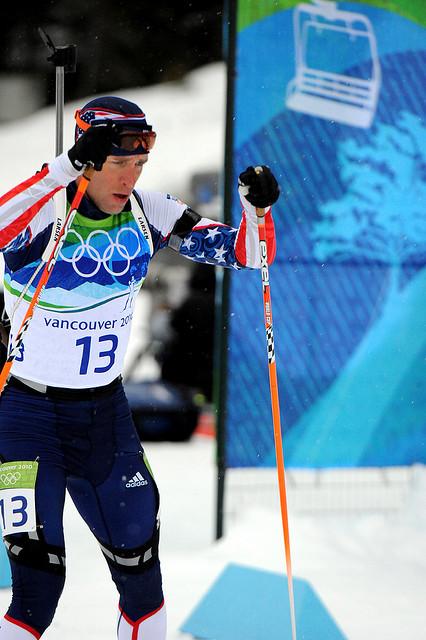Does he look distressed?
Concise answer only. Yes. What year was this photo taken?
Write a very short answer. 2010. What major sporting event is he a part of?
Keep it brief. Olympics. What number is the man wearing on his shirt?
Short answer required. 13. 